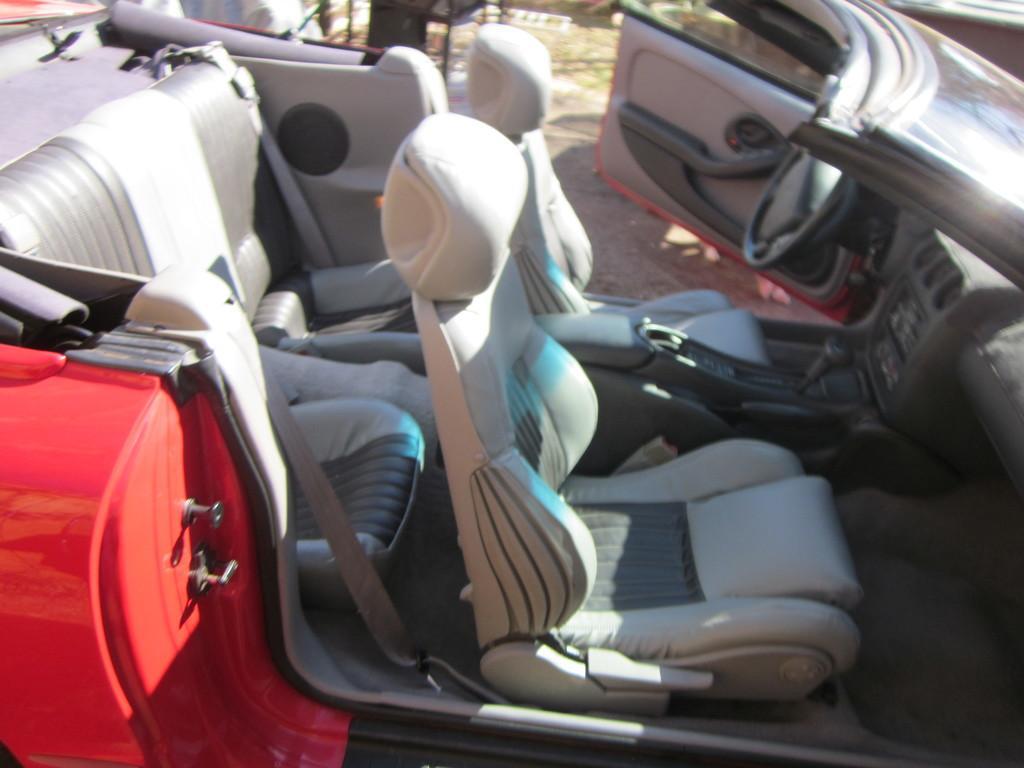Describe this image in one or two sentences. In this picture there is a car which has few seats and steering in it. 